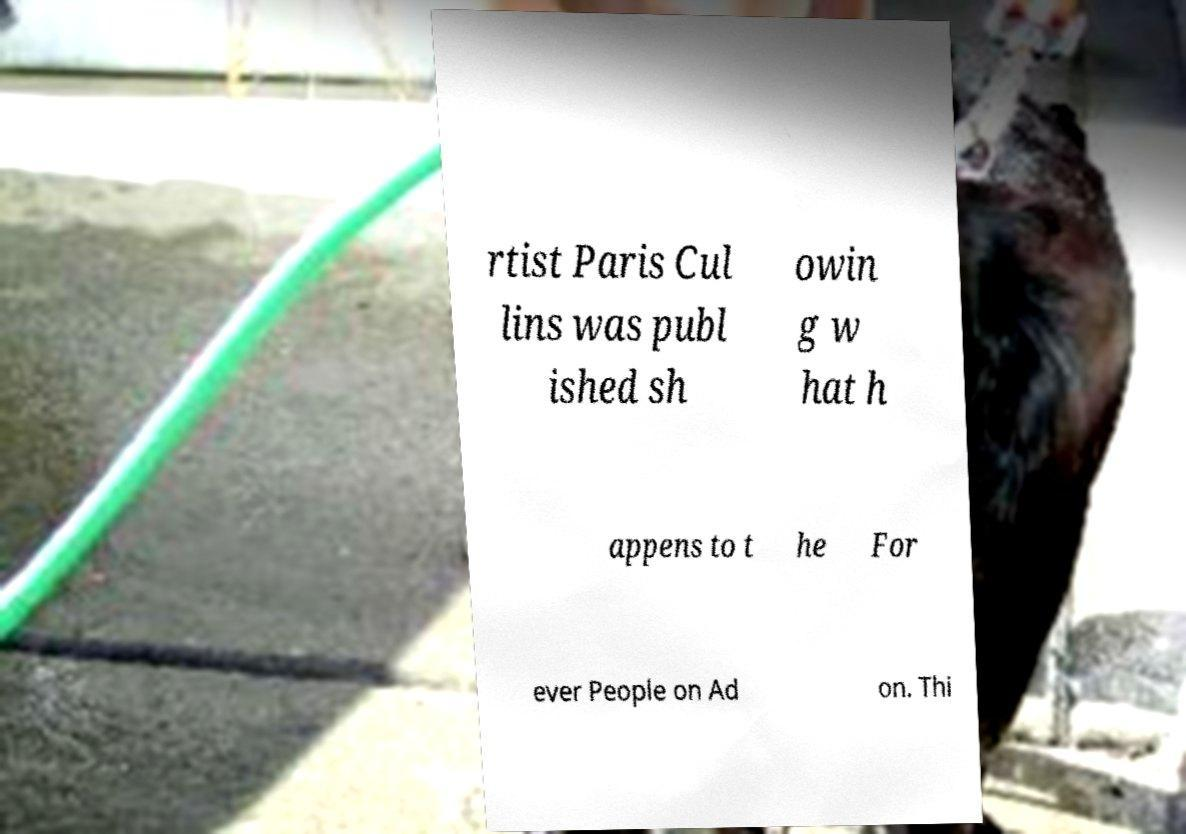What messages or text are displayed in this image? I need them in a readable, typed format. rtist Paris Cul lins was publ ished sh owin g w hat h appens to t he For ever People on Ad on. Thi 